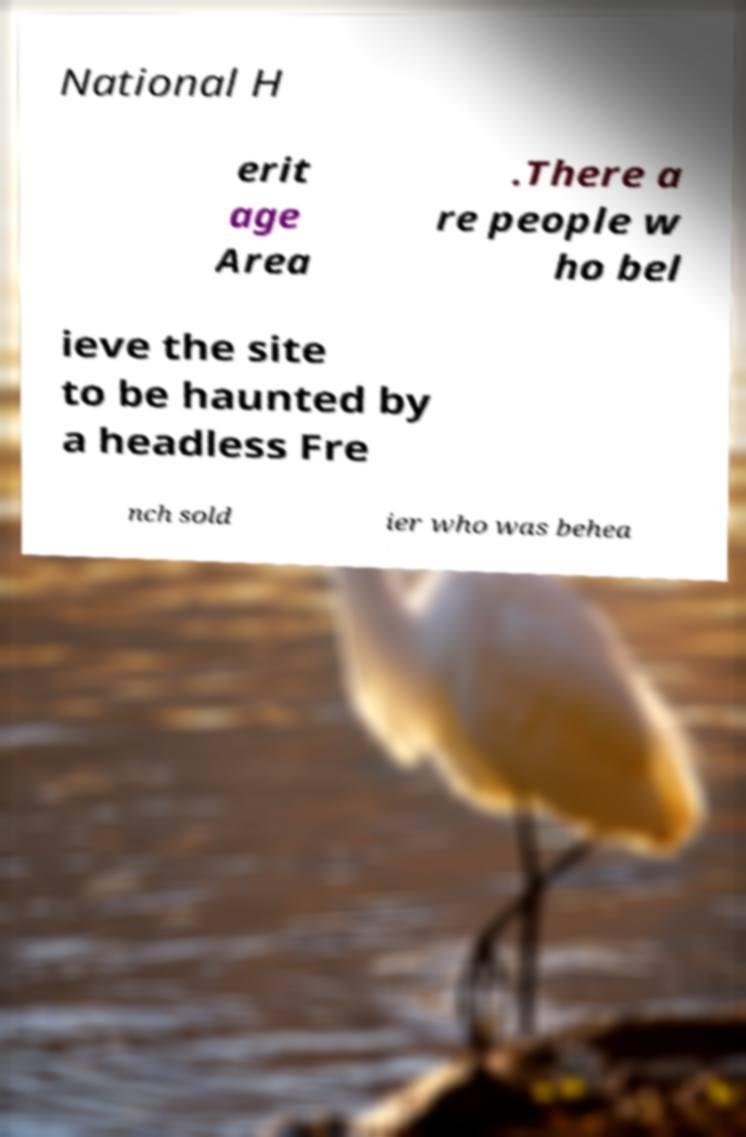Can you accurately transcribe the text from the provided image for me? National H erit age Area .There a re people w ho bel ieve the site to be haunted by a headless Fre nch sold ier who was behea 